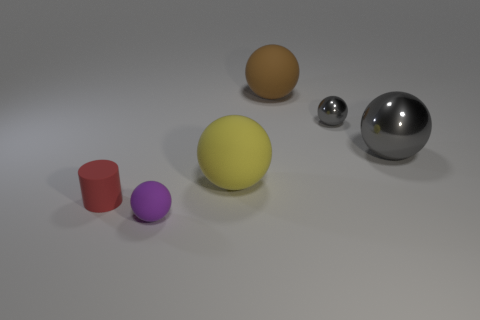Add 1 metallic blocks. How many objects exist? 7 Subtract all gray spheres. How many spheres are left? 3 Subtract all cylinders. How many objects are left? 5 Subtract 4 balls. How many balls are left? 1 Add 4 small gray metallic spheres. How many small gray metallic spheres exist? 5 Subtract all gray spheres. How many spheres are left? 3 Subtract 0 cyan cylinders. How many objects are left? 6 Subtract all cyan spheres. Subtract all blue cylinders. How many spheres are left? 5 Subtract all blue blocks. How many yellow cylinders are left? 0 Subtract all tiny metallic balls. Subtract all gray metallic balls. How many objects are left? 3 